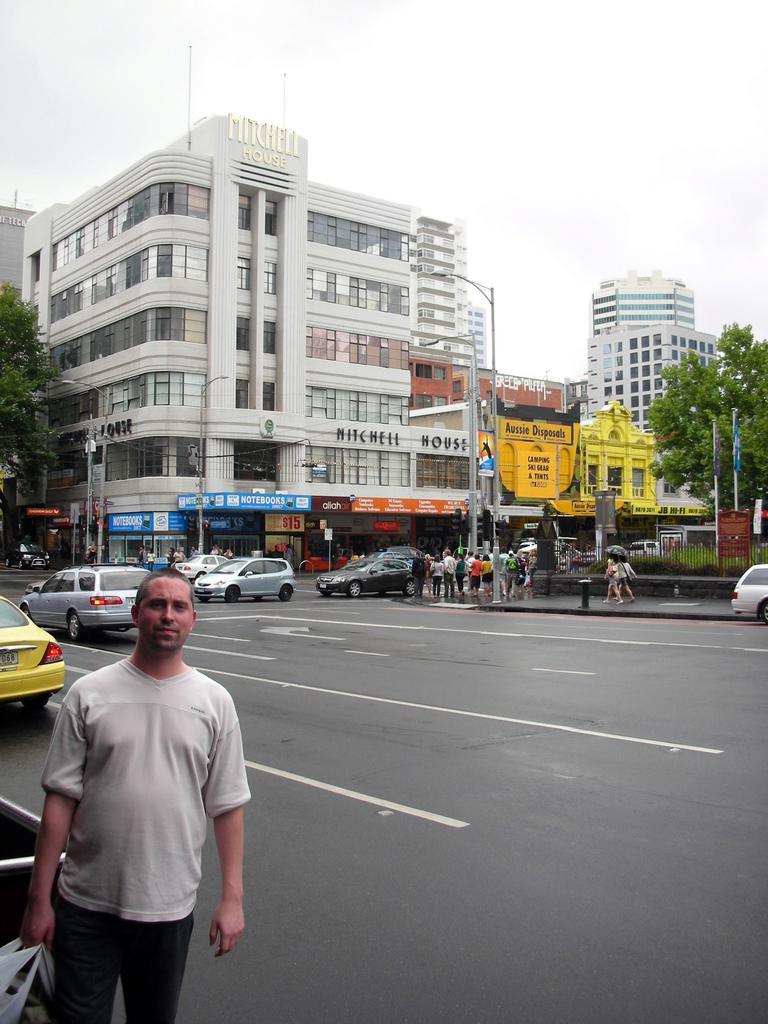Please provide a concise description of this image. In this image I see man over here who is standing and I see that he is holding a bag in his hand. In the background I see the road on which there are vehicles and I see the buildings, trees, light poles and few more people over here and I see the sky. 